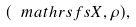<formula> <loc_0><loc_0><loc_500><loc_500>( \ m a t h r s f s { X } , \rho ) ,</formula> 